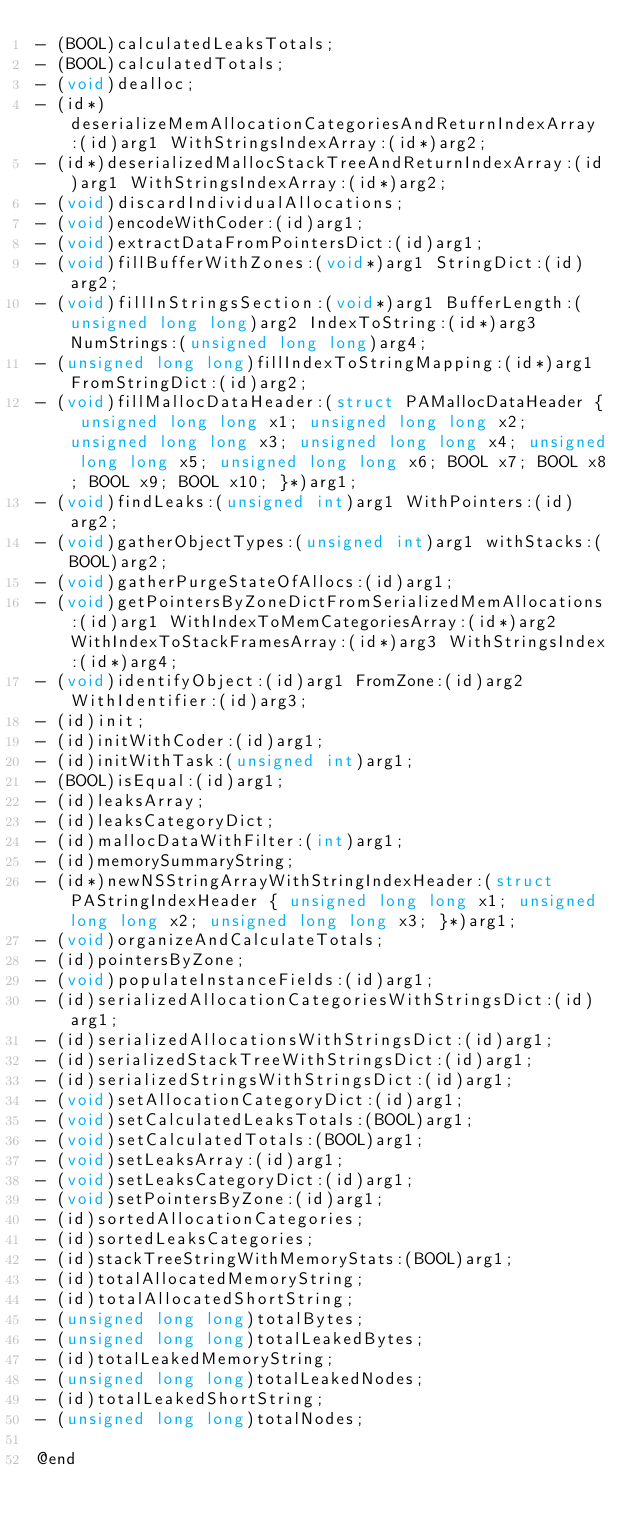Convert code to text. <code><loc_0><loc_0><loc_500><loc_500><_C_>- (BOOL)calculatedLeaksTotals;
- (BOOL)calculatedTotals;
- (void)dealloc;
- (id*)deserializeMemAllocationCategoriesAndReturnIndexArray:(id)arg1 WithStringsIndexArray:(id*)arg2;
- (id*)deserializedMallocStackTreeAndReturnIndexArray:(id)arg1 WithStringsIndexArray:(id*)arg2;
- (void)discardIndividualAllocations;
- (void)encodeWithCoder:(id)arg1;
- (void)extractDataFromPointersDict:(id)arg1;
- (void)fillBufferWithZones:(void*)arg1 StringDict:(id)arg2;
- (void)fillInStringsSection:(void*)arg1 BufferLength:(unsigned long long)arg2 IndexToString:(id*)arg3 NumStrings:(unsigned long long)arg4;
- (unsigned long long)fillIndexToStringMapping:(id*)arg1 FromStringDict:(id)arg2;
- (void)fillMallocDataHeader:(struct PAMallocDataHeader { unsigned long long x1; unsigned long long x2; unsigned long long x3; unsigned long long x4; unsigned long long x5; unsigned long long x6; BOOL x7; BOOL x8; BOOL x9; BOOL x10; }*)arg1;
- (void)findLeaks:(unsigned int)arg1 WithPointers:(id)arg2;
- (void)gatherObjectTypes:(unsigned int)arg1 withStacks:(BOOL)arg2;
- (void)gatherPurgeStateOfAllocs:(id)arg1;
- (void)getPointersByZoneDictFromSerializedMemAllocations:(id)arg1 WithIndexToMemCategoriesArray:(id*)arg2 WithIndexToStackFramesArray:(id*)arg3 WithStringsIndex:(id*)arg4;
- (void)identifyObject:(id)arg1 FromZone:(id)arg2 WithIdentifier:(id)arg3;
- (id)init;
- (id)initWithCoder:(id)arg1;
- (id)initWithTask:(unsigned int)arg1;
- (BOOL)isEqual:(id)arg1;
- (id)leaksArray;
- (id)leaksCategoryDict;
- (id)mallocDataWithFilter:(int)arg1;
- (id)memorySummaryString;
- (id*)newNSStringArrayWithStringIndexHeader:(struct PAStringIndexHeader { unsigned long long x1; unsigned long long x2; unsigned long long x3; }*)arg1;
- (void)organizeAndCalculateTotals;
- (id)pointersByZone;
- (void)populateInstanceFields:(id)arg1;
- (id)serializedAllocationCategoriesWithStringsDict:(id)arg1;
- (id)serializedAllocationsWithStringsDict:(id)arg1;
- (id)serializedStackTreeWithStringsDict:(id)arg1;
- (id)serializedStringsWithStringsDict:(id)arg1;
- (void)setAllocationCategoryDict:(id)arg1;
- (void)setCalculatedLeaksTotals:(BOOL)arg1;
- (void)setCalculatedTotals:(BOOL)arg1;
- (void)setLeaksArray:(id)arg1;
- (void)setLeaksCategoryDict:(id)arg1;
- (void)setPointersByZone:(id)arg1;
- (id)sortedAllocationCategories;
- (id)sortedLeaksCategories;
- (id)stackTreeStringWithMemoryStats:(BOOL)arg1;
- (id)totalAllocatedMemoryString;
- (id)totalAllocatedShortString;
- (unsigned long long)totalBytes;
- (unsigned long long)totalLeakedBytes;
- (id)totalLeakedMemoryString;
- (unsigned long long)totalLeakedNodes;
- (id)totalLeakedShortString;
- (unsigned long long)totalNodes;

@end
</code> 